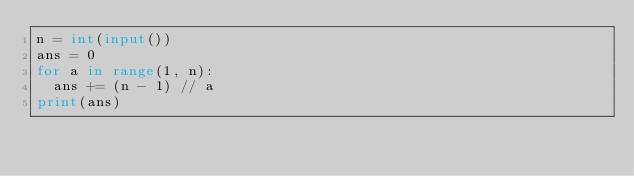Convert code to text. <code><loc_0><loc_0><loc_500><loc_500><_Python_>n = int(input())
ans = 0
for a in range(1, n):
  ans += (n - 1) // a
print(ans)
</code> 